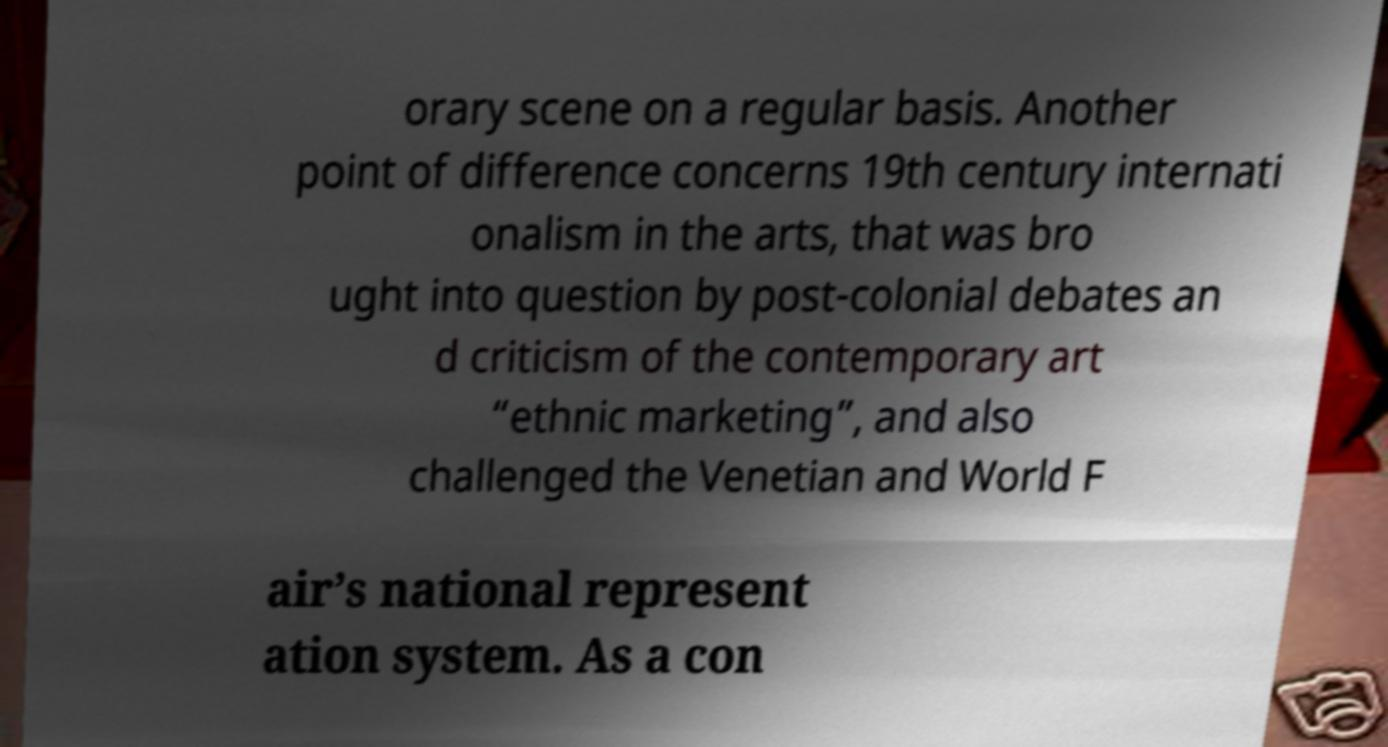I need the written content from this picture converted into text. Can you do that? orary scene on a regular basis. Another point of difference concerns 19th century internati onalism in the arts, that was bro ught into question by post-colonial debates an d criticism of the contemporary art “ethnic marketing”, and also challenged the Venetian and World F air’s national represent ation system. As a con 